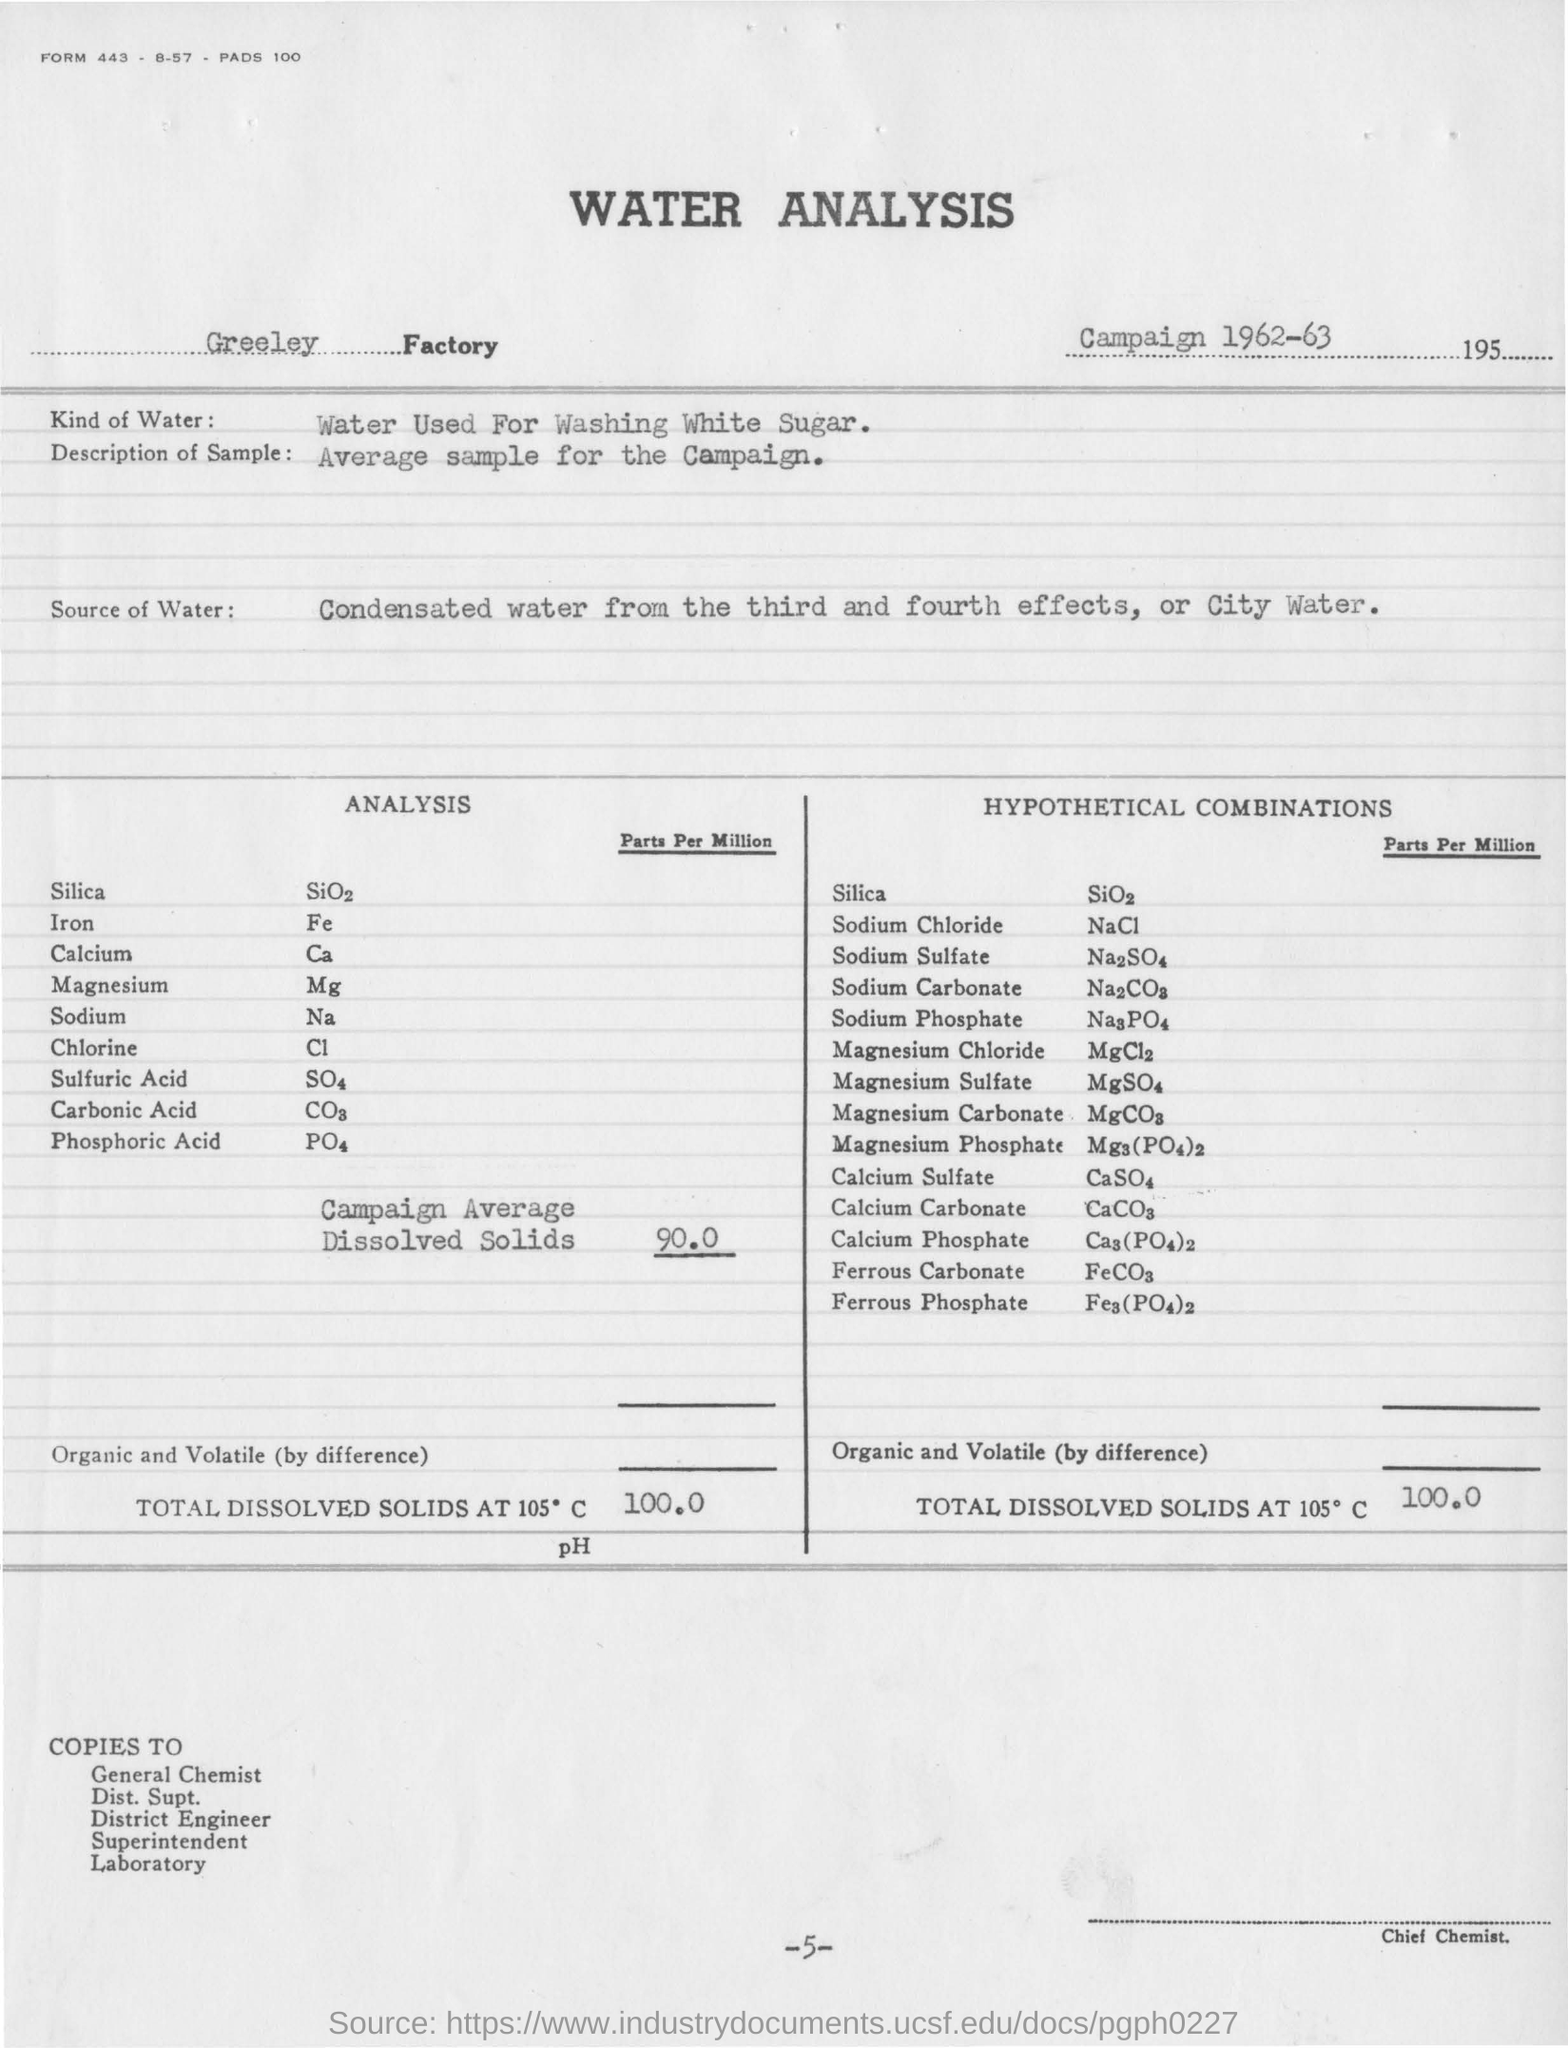When campaign was conducted for water analysis?
Provide a short and direct response. 1962-63. Where is the source of water for water anslysis?
Offer a terse response. Condensated water from the third and fourth effects, or city water. What is the campaign average dissolved solids  parts per million?
Give a very brief answer. 90.0. 